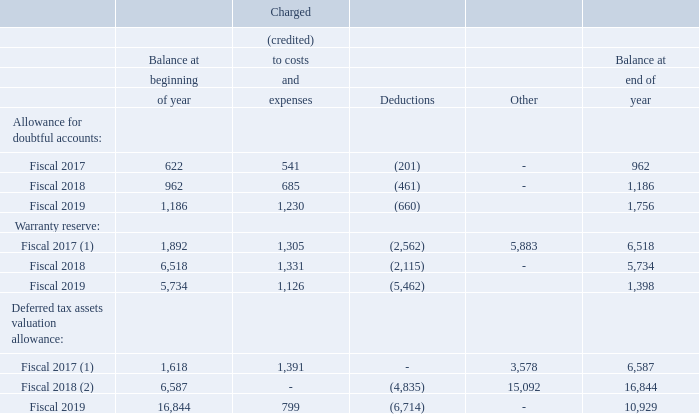Valuation and Qualifying Accounts
Following is our schedule of valuation and qualifying accounts for the last three years (in thousands):
(1) Amounts under “Other” represent the reserves and valuation allowance assumed in acquisition of LoJack.
The warranty reserve is included in the Other Current Liabilities in the consolidated balance sheets.
(2) Amount under “Other” represents the valuation allowance previously netted against deferred tax assets of foreign net deferred tax assets not recorded on the balance sheet, which were disclosed narratively in the fiscal 2018 Form 10-K (see Note 12). Deferred tax assets and valuation allowances were grossed up by $15.1 million.
What do the amounts under "Other" represnet? The reserves and valuation allowance assumed in acquisition of lojack. What was the warranty reserve balance at the beginning of fiscal year 2018?
Answer scale should be: thousand. 6,518. What was the allowance for doubtful accounts balance at the beginning of fiscal year 2019?
Answer scale should be: thousand. 1,186. What was the difference in the balance at the end of the year compared to the start of the year for warranty reserve in fiscal year 2017?
Answer scale should be: thousand. (6,518-1,892)
Answer: 4626. What was the change in the balance at the beginning of the year for allowance for doubtful accounts between fiscal year 2018 and 2019?
Answer scale should be: thousand. (1,186-962)
Answer: 224. What was the change in Other from Deferred tax assets valuation allowance between Fiscal 2017 and 2018?
Answer scale should be: thousand. (15,092-3,578)
Answer: 11514. 